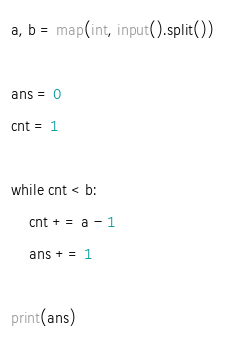<code> <loc_0><loc_0><loc_500><loc_500><_Python_>a, b = map(int, input().split())

ans = 0
cnt = 1

while cnt < b:
    cnt += a - 1
    ans += 1

print(ans)</code> 